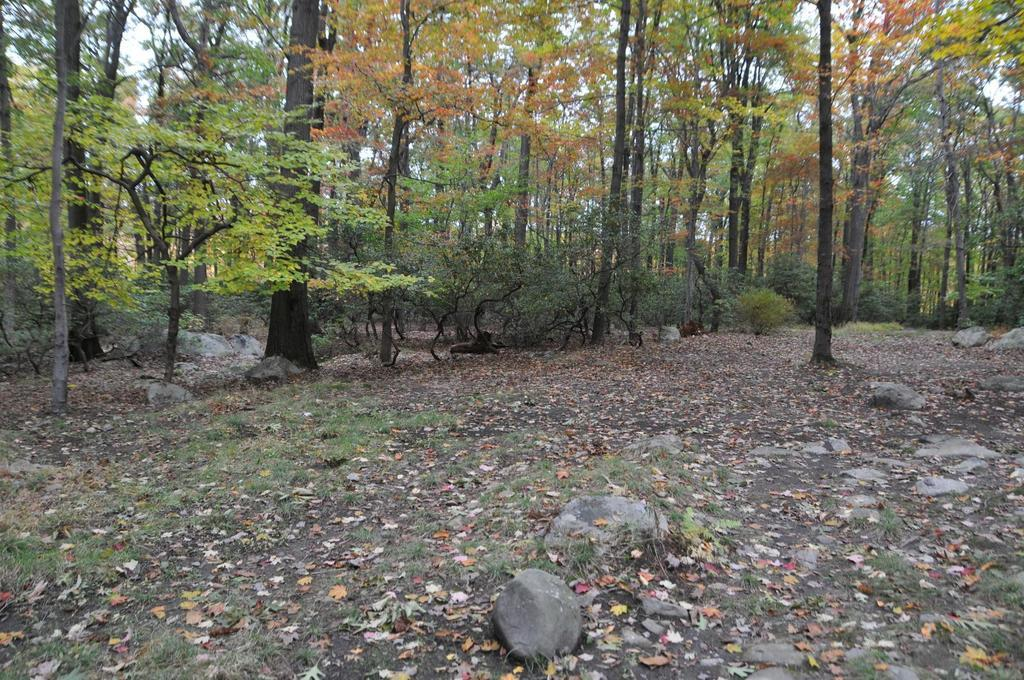What type of vegetation can be seen in the image? There are trees with branches and leaves in the image. What else is present on the ground in the image? Rocks and dried leaves are visible on the ground in the image. What type of ground cover can be seen in the image? There is grass in the image. What type of cough medicine is visible in the image? There is no cough medicine present in the image. Can you see an arch in the image? There is no arch present in the image. 